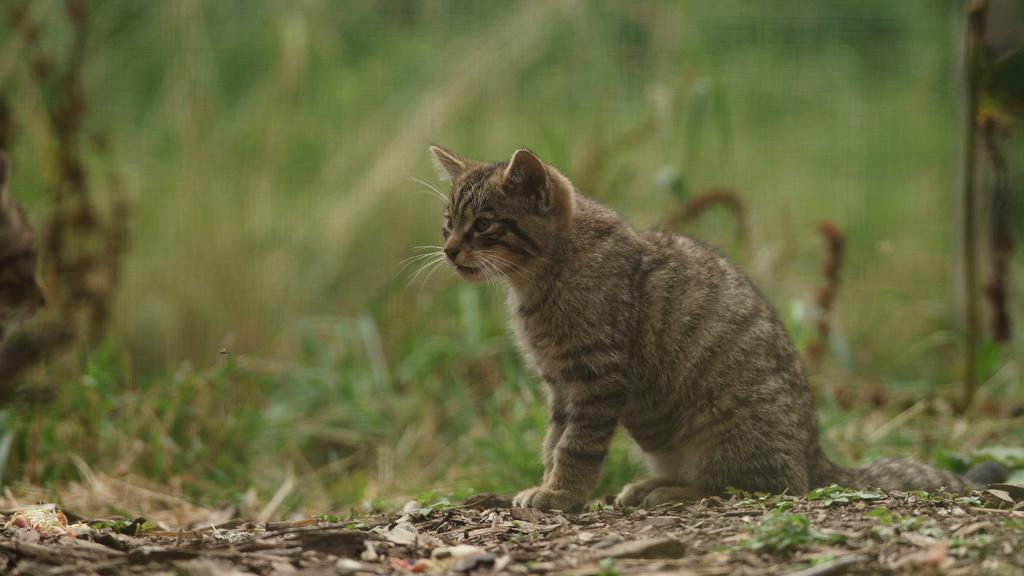What type of animal is in the image? There is a cat in the image. Where is the cat located in the image? The cat is sitting on the ground. What type of tools does the cat use as a carpenter in the image? There is no indication that the cat is a carpenter or using any tools in the image. 